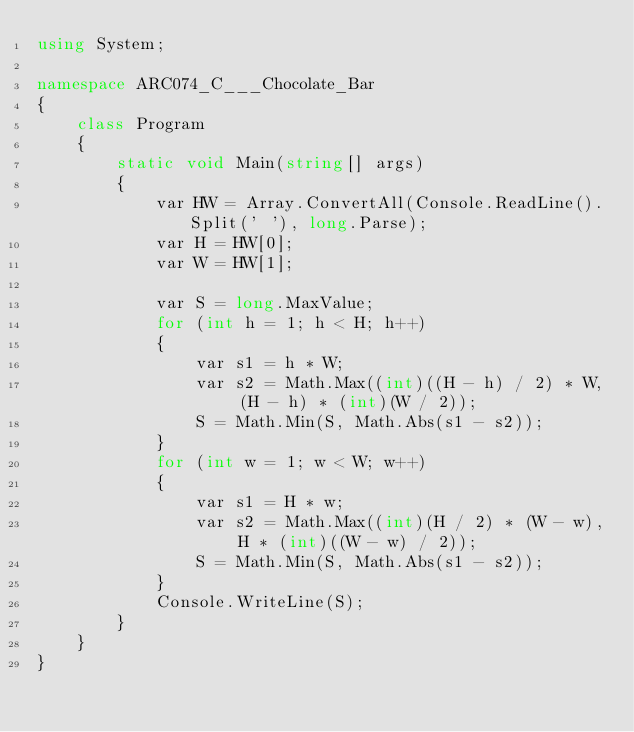<code> <loc_0><loc_0><loc_500><loc_500><_C#_>using System;

namespace ARC074_C___Chocolate_Bar
{
    class Program
    {
        static void Main(string[] args)
        {
            var HW = Array.ConvertAll(Console.ReadLine().Split(' '), long.Parse);
            var H = HW[0];
            var W = HW[1];

            var S = long.MaxValue;
            for (int h = 1; h < H; h++)
            {
                var s1 = h * W;
                var s2 = Math.Max((int)((H - h) / 2) * W, (H - h) * (int)(W / 2));
                S = Math.Min(S, Math.Abs(s1 - s2));
            }
            for (int w = 1; w < W; w++)
            {
                var s1 = H * w;
                var s2 = Math.Max((int)(H / 2) * (W - w), H * (int)((W - w) / 2));
                S = Math.Min(S, Math.Abs(s1 - s2));
            }
            Console.WriteLine(S);
        }
    }
}
</code> 